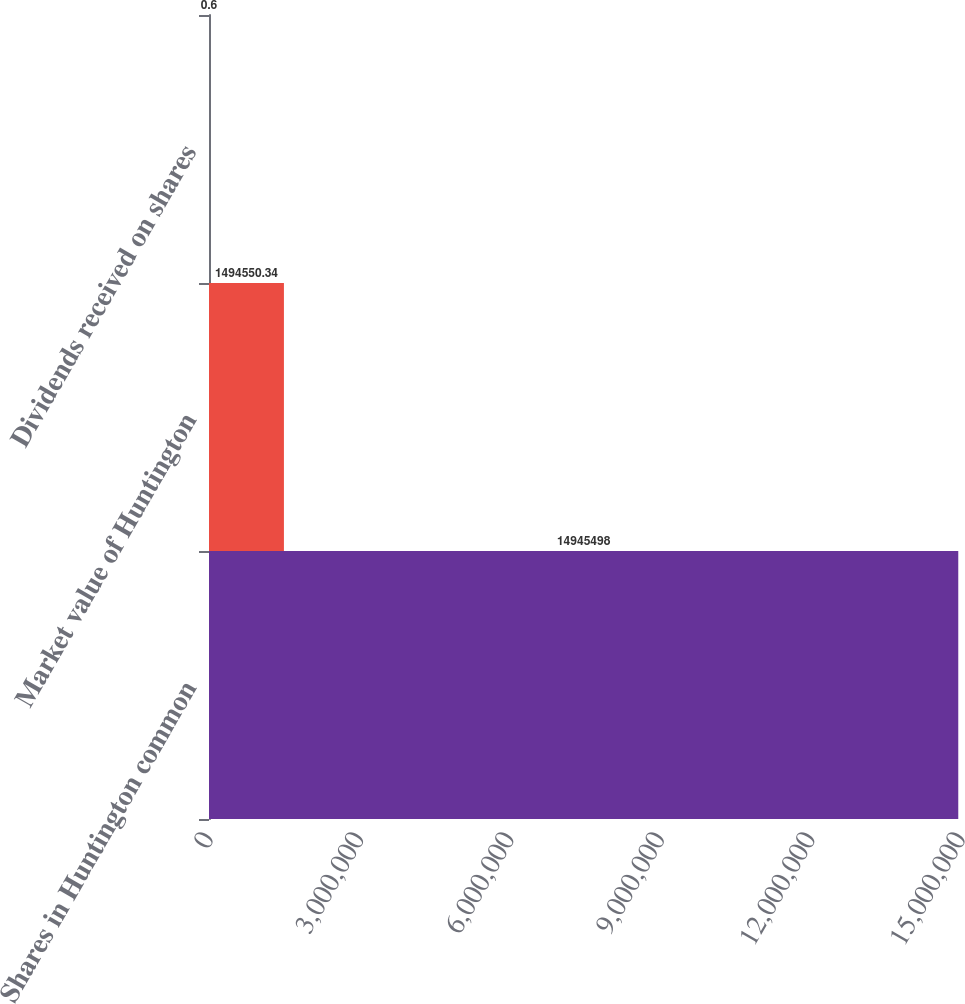Convert chart to OTSL. <chart><loc_0><loc_0><loc_500><loc_500><bar_chart><fcel>Shares in Huntington common<fcel>Market value of Huntington<fcel>Dividends received on shares<nl><fcel>1.49455e+07<fcel>1.49455e+06<fcel>0.6<nl></chart> 